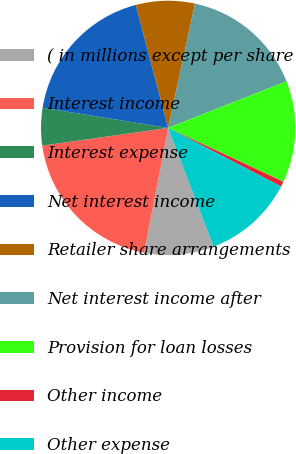<chart> <loc_0><loc_0><loc_500><loc_500><pie_chart><fcel>( in millions except per share<fcel>Interest income<fcel>Interest expense<fcel>Net interest income<fcel>Retailer share arrangements<fcel>Net interest income after<fcel>Provision for loan losses<fcel>Other income<fcel>Other expense<nl><fcel>8.84%<fcel>19.74%<fcel>4.76%<fcel>18.37%<fcel>7.48%<fcel>15.65%<fcel>12.93%<fcel>0.67%<fcel>11.57%<nl></chart> 